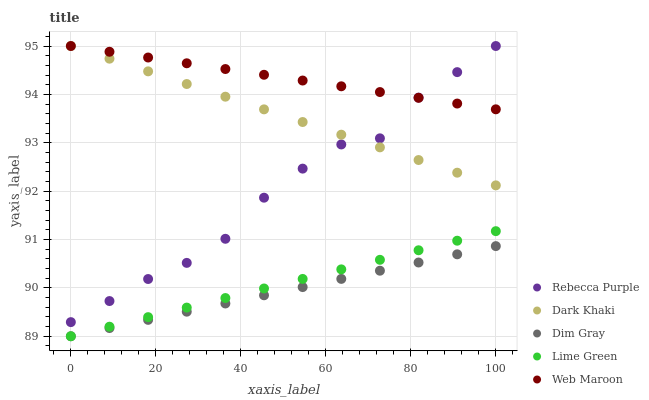Does Dim Gray have the minimum area under the curve?
Answer yes or no. Yes. Does Web Maroon have the maximum area under the curve?
Answer yes or no. Yes. Does Web Maroon have the minimum area under the curve?
Answer yes or no. No. Does Dim Gray have the maximum area under the curve?
Answer yes or no. No. Is Dim Gray the smoothest?
Answer yes or no. Yes. Is Rebecca Purple the roughest?
Answer yes or no. Yes. Is Web Maroon the smoothest?
Answer yes or no. No. Is Web Maroon the roughest?
Answer yes or no. No. Does Dim Gray have the lowest value?
Answer yes or no. Yes. Does Web Maroon have the lowest value?
Answer yes or no. No. Does Rebecca Purple have the highest value?
Answer yes or no. Yes. Does Dim Gray have the highest value?
Answer yes or no. No. Is Dim Gray less than Dark Khaki?
Answer yes or no. Yes. Is Rebecca Purple greater than Lime Green?
Answer yes or no. Yes. Does Rebecca Purple intersect Web Maroon?
Answer yes or no. Yes. Is Rebecca Purple less than Web Maroon?
Answer yes or no. No. Is Rebecca Purple greater than Web Maroon?
Answer yes or no. No. Does Dim Gray intersect Dark Khaki?
Answer yes or no. No. 